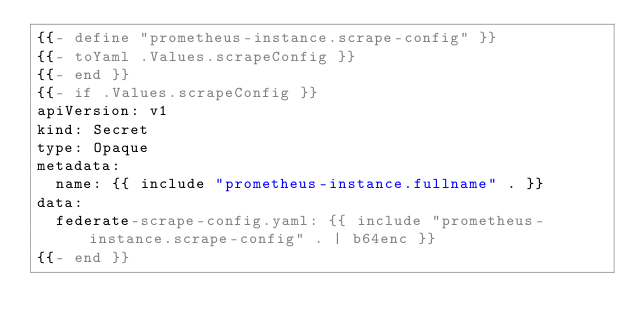<code> <loc_0><loc_0><loc_500><loc_500><_YAML_>{{- define "prometheus-instance.scrape-config" }}
{{- toYaml .Values.scrapeConfig }}
{{- end }}
{{- if .Values.scrapeConfig }}
apiVersion: v1
kind: Secret
type: Opaque
metadata:
  name: {{ include "prometheus-instance.fullname" . }}
data:
  federate-scrape-config.yaml: {{ include "prometheus-instance.scrape-config" . | b64enc }}
{{- end }}
</code> 